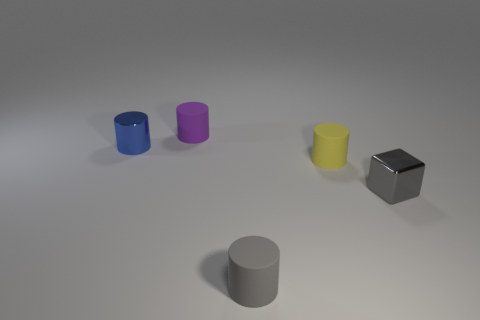How many tiny blue objects are the same shape as the tiny yellow matte thing?
Your response must be concise. 1. Is the material of the purple cylinder the same as the yellow object?
Ensure brevity in your answer.  Yes. The tiny thing that is behind the tiny blue object that is to the left of the small gray metal cube is what shape?
Make the answer very short. Cylinder. What number of small yellow matte things are in front of the matte object in front of the gray metallic thing?
Make the answer very short. 0. What is the small thing that is in front of the tiny blue cylinder and behind the gray metallic object made of?
Your response must be concise. Rubber. There is a purple matte thing that is the same size as the gray shiny thing; what shape is it?
Keep it short and to the point. Cylinder. What is the color of the cylinder that is behind the small cylinder that is left of the small cylinder behind the blue object?
Offer a terse response. Purple. What number of objects are small rubber cylinders in front of the tiny metallic block or gray metal balls?
Provide a succinct answer. 1. There is a yellow thing that is the same size as the gray metallic cube; what is its material?
Make the answer very short. Rubber. The yellow cylinder behind the tiny metal object right of the tiny metallic thing that is left of the tiny gray block is made of what material?
Your response must be concise. Rubber. 